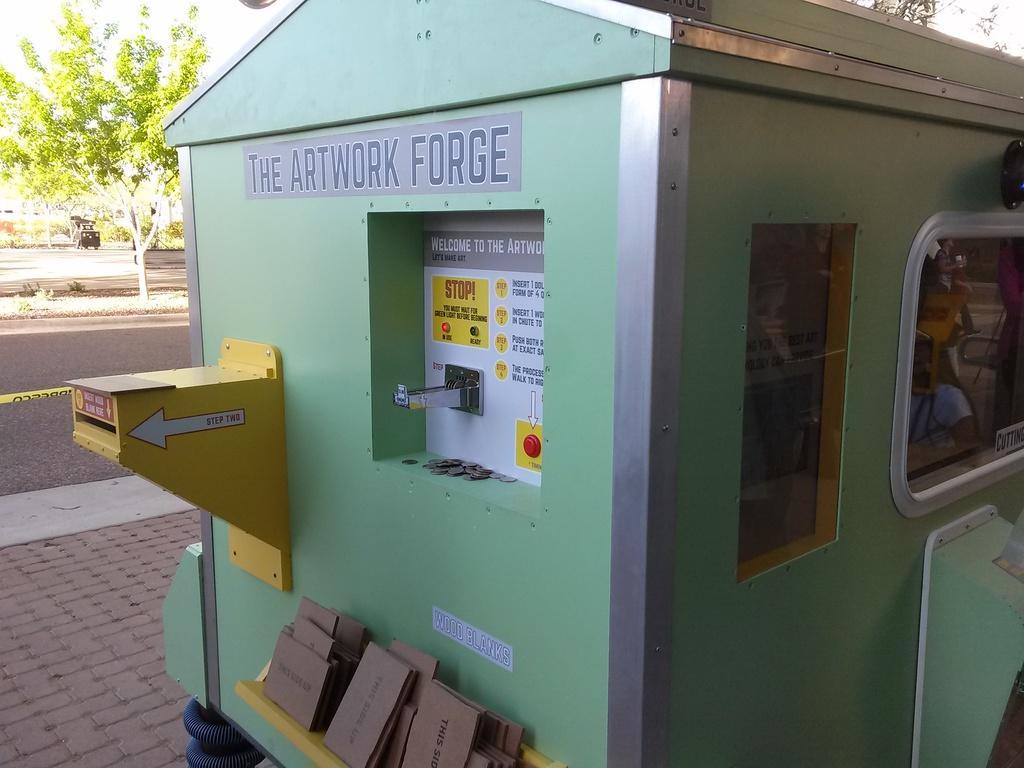Describe this image in one or two sentences. In this image I can see a machine in green color, on the left side there is the road and a green tree. At the bottom it is the footpath. 